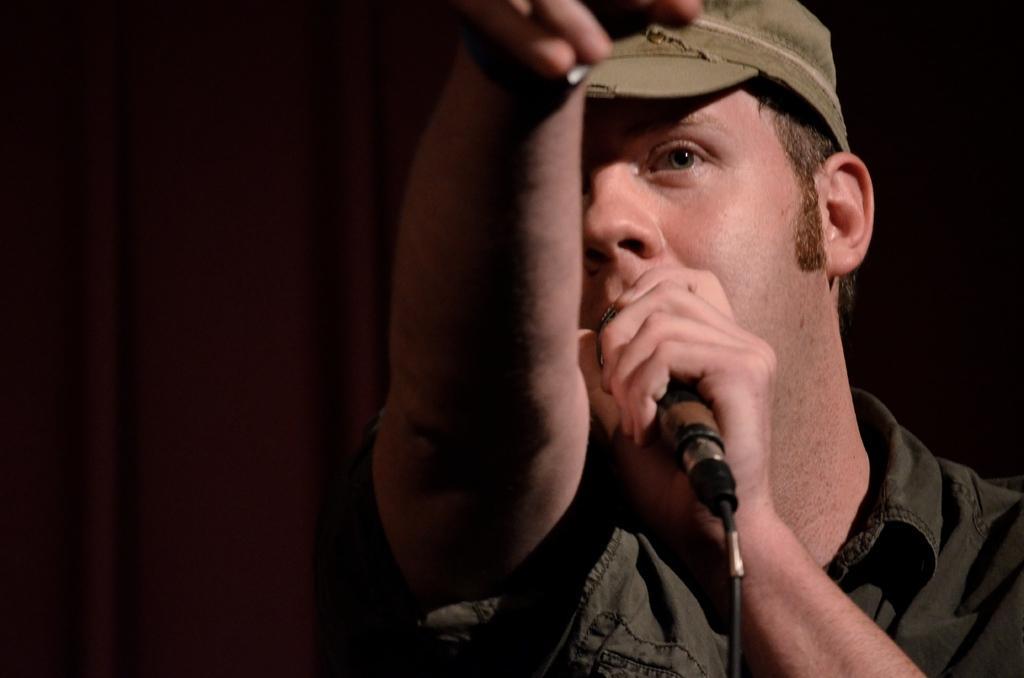Please provide a concise description of this image. In the picture,there is a man,he is wearing a hat,he is holding a mic he is speaking something,in the background it is black,to his left side there is a curtain. 